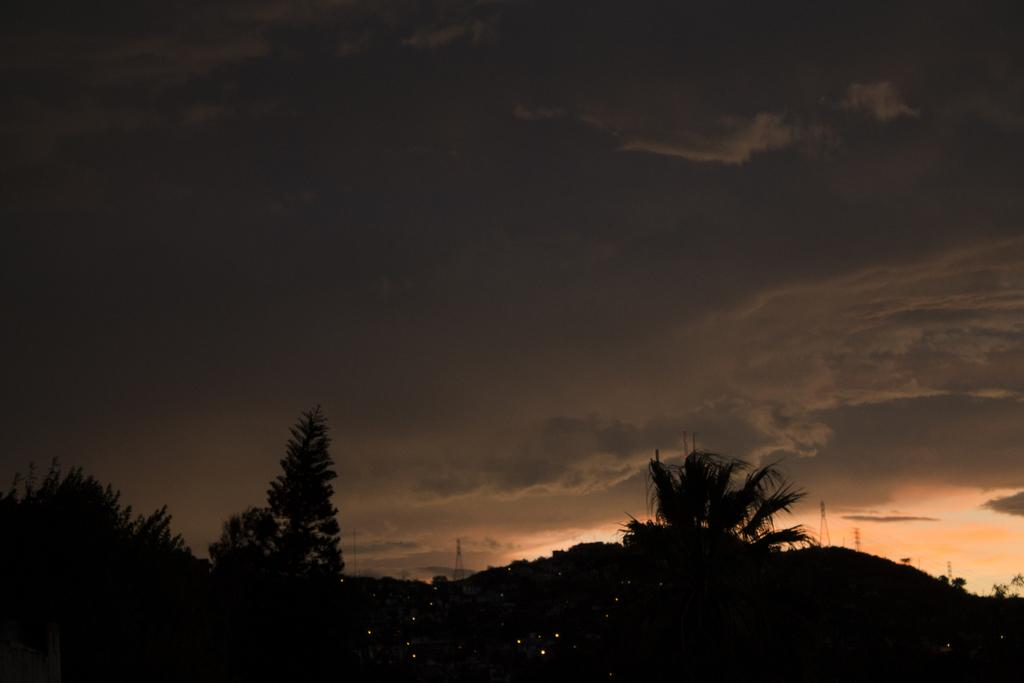What type of vegetation can be seen in the image? There are trees in the image. What part of the natural environment is visible in the image? The sky is visible in the background of the image. What type of steel is being used to support the trees in the image? There is no steel present in the image; the trees are supported by their own trunks and roots. 